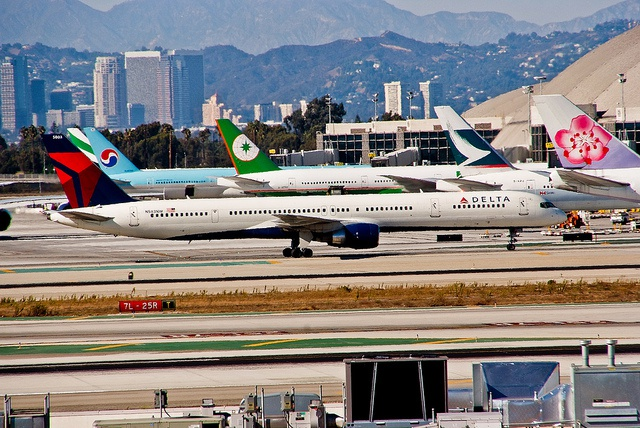Describe the objects in this image and their specific colors. I can see airplane in gray, lightgray, black, and darkgray tones, airplane in gray, lightgray, black, and darkgray tones, airplane in gray, lightgray, darkgray, and lightpink tones, airplane in gray, lightgray, darkgreen, black, and darkgray tones, and airplane in gray, lightblue, and lightgray tones in this image. 